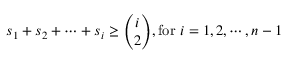<formula> <loc_0><loc_0><loc_500><loc_500>s _ { 1 } + s _ { 2 } + \cdots + s _ { i } \geq { \binom { i } { 2 } } , { f o r } i = 1 , 2 , \cdots , n - 1</formula> 